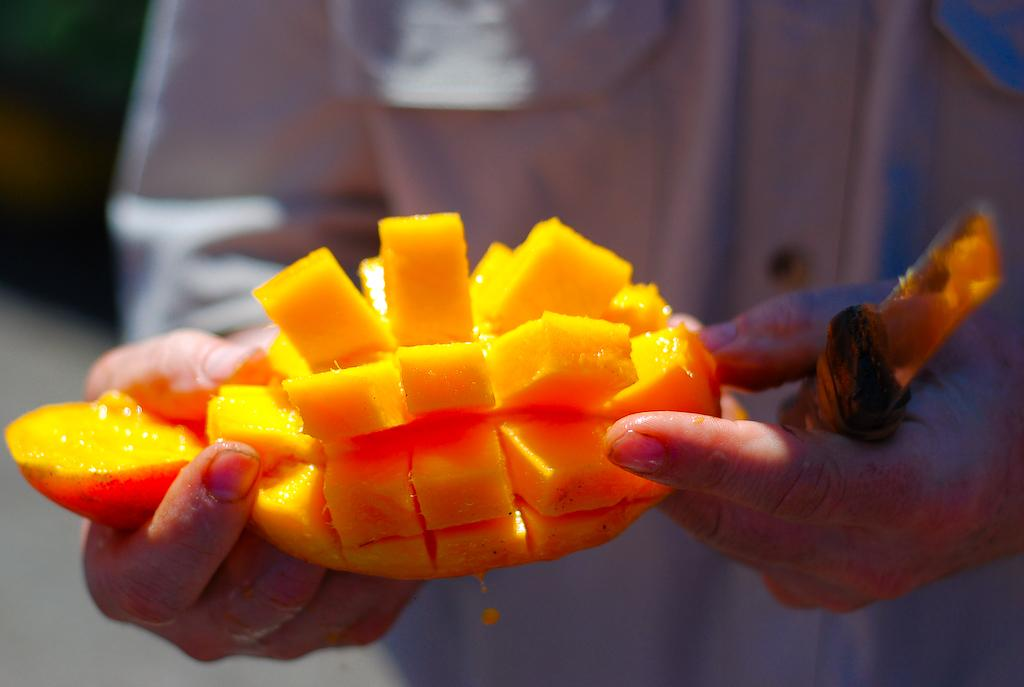What is the main subject of the image? There is a person in the image. What is the person doing in the image? The person is standing and holding a knife. What can be seen in the image besides the person? Sliced mangoes are present in the image. Are there any cobwebs visible in the image? There is no mention of cobwebs in the provided facts, and therefore we cannot determine if any are present in the image. 